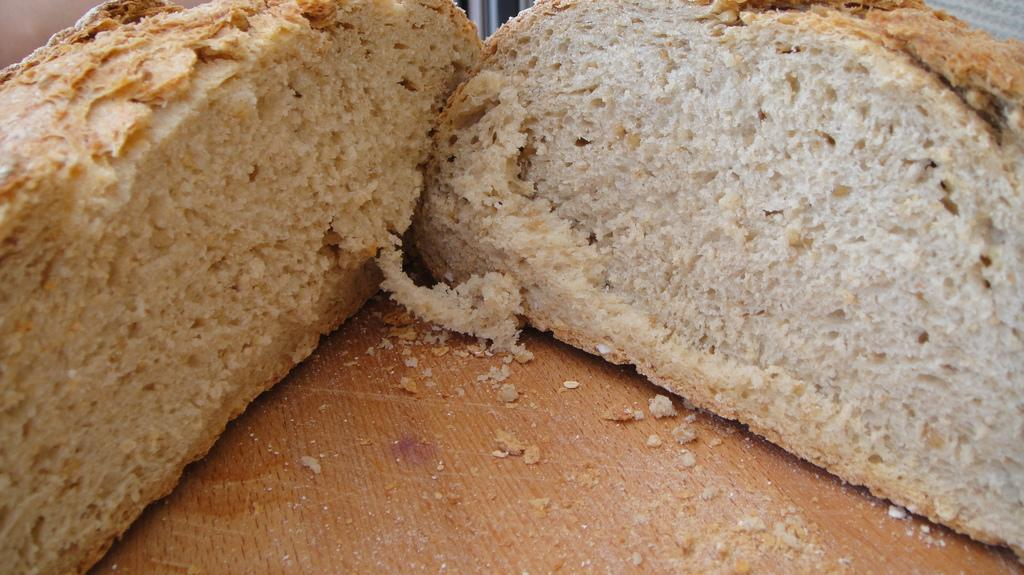How many pieces of bread are visible in the image? There are 2 pieces of bread in the image. What is the color of the surface in the image? The surface in the image has a brown color. What type of clouds can be seen in the image? There are no clouds visible in the image; it only features 2 pieces of bread on a brown surface. 